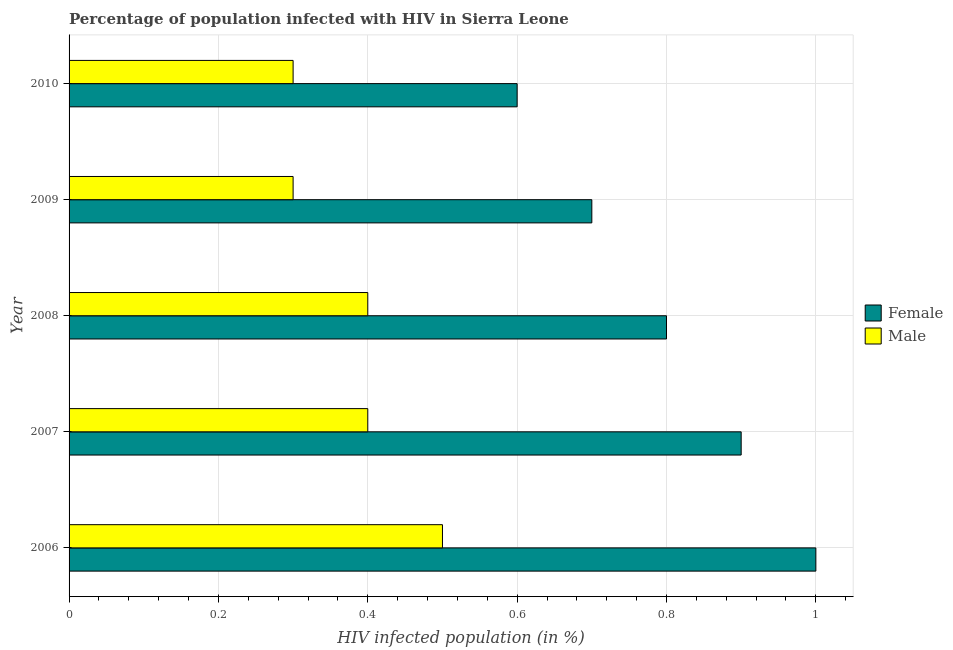How many bars are there on the 2nd tick from the top?
Offer a terse response. 2. What is the label of the 2nd group of bars from the top?
Give a very brief answer. 2009. What is the percentage of males who are infected with hiv in 2009?
Offer a very short reply. 0.3. What is the total percentage of males who are infected with hiv in the graph?
Provide a short and direct response. 1.9. What is the difference between the percentage of males who are infected with hiv in 2007 and that in 2009?
Keep it short and to the point. 0.1. What is the difference between the percentage of males who are infected with hiv in 2009 and the percentage of females who are infected with hiv in 2007?
Your answer should be very brief. -0.6. What is the average percentage of males who are infected with hiv per year?
Provide a short and direct response. 0.38. What is the ratio of the percentage of females who are infected with hiv in 2009 to that in 2010?
Offer a terse response. 1.17. Is the percentage of females who are infected with hiv in 2006 less than that in 2008?
Give a very brief answer. No. What is the difference between the highest and the lowest percentage of females who are infected with hiv?
Keep it short and to the point. 0.4. Is the sum of the percentage of males who are infected with hiv in 2007 and 2010 greater than the maximum percentage of females who are infected with hiv across all years?
Offer a very short reply. No. What does the 2nd bar from the top in 2009 represents?
Keep it short and to the point. Female. What does the 1st bar from the bottom in 2009 represents?
Provide a succinct answer. Female. How many bars are there?
Your response must be concise. 10. Are all the bars in the graph horizontal?
Your answer should be very brief. Yes. How many years are there in the graph?
Your response must be concise. 5. What is the difference between two consecutive major ticks on the X-axis?
Your answer should be very brief. 0.2. Are the values on the major ticks of X-axis written in scientific E-notation?
Offer a very short reply. No. Does the graph contain any zero values?
Offer a terse response. No. Does the graph contain grids?
Keep it short and to the point. Yes. Where does the legend appear in the graph?
Offer a terse response. Center right. What is the title of the graph?
Your answer should be compact. Percentage of population infected with HIV in Sierra Leone. What is the label or title of the X-axis?
Your answer should be very brief. HIV infected population (in %). What is the HIV infected population (in %) in Female in 2006?
Give a very brief answer. 1. What is the HIV infected population (in %) of Male in 2006?
Provide a succinct answer. 0.5. What is the HIV infected population (in %) in Female in 2007?
Your answer should be very brief. 0.9. What is the HIV infected population (in %) in Male in 2007?
Give a very brief answer. 0.4. What is the HIV infected population (in %) of Female in 2009?
Keep it short and to the point. 0.7. What is the HIV infected population (in %) of Male in 2010?
Make the answer very short. 0.3. Across all years, what is the maximum HIV infected population (in %) of Male?
Offer a terse response. 0.5. Across all years, what is the minimum HIV infected population (in %) of Female?
Offer a terse response. 0.6. Across all years, what is the minimum HIV infected population (in %) of Male?
Offer a very short reply. 0.3. What is the difference between the HIV infected population (in %) in Male in 2006 and that in 2007?
Your response must be concise. 0.1. What is the difference between the HIV infected population (in %) of Female in 2006 and that in 2008?
Make the answer very short. 0.2. What is the difference between the HIV infected population (in %) in Male in 2006 and that in 2008?
Ensure brevity in your answer.  0.1. What is the difference between the HIV infected population (in %) of Female in 2006 and that in 2010?
Give a very brief answer. 0.4. What is the difference between the HIV infected population (in %) of Male in 2007 and that in 2008?
Make the answer very short. 0. What is the difference between the HIV infected population (in %) of Male in 2007 and that in 2009?
Ensure brevity in your answer.  0.1. What is the difference between the HIV infected population (in %) of Male in 2007 and that in 2010?
Your answer should be very brief. 0.1. What is the difference between the HIV infected population (in %) in Female in 2008 and that in 2010?
Make the answer very short. 0.2. What is the difference between the HIV infected population (in %) of Male in 2008 and that in 2010?
Offer a very short reply. 0.1. What is the difference between the HIV infected population (in %) in Male in 2009 and that in 2010?
Your answer should be compact. 0. What is the difference between the HIV infected population (in %) in Female in 2006 and the HIV infected population (in %) in Male in 2008?
Your answer should be compact. 0.6. What is the difference between the HIV infected population (in %) of Female in 2006 and the HIV infected population (in %) of Male in 2009?
Make the answer very short. 0.7. What is the difference between the HIV infected population (in %) of Female in 2006 and the HIV infected population (in %) of Male in 2010?
Your answer should be very brief. 0.7. What is the difference between the HIV infected population (in %) in Female in 2007 and the HIV infected population (in %) in Male in 2008?
Offer a terse response. 0.5. What is the difference between the HIV infected population (in %) in Female in 2007 and the HIV infected population (in %) in Male in 2009?
Give a very brief answer. 0.6. What is the difference between the HIV infected population (in %) in Female in 2007 and the HIV infected population (in %) in Male in 2010?
Your answer should be very brief. 0.6. What is the difference between the HIV infected population (in %) of Female in 2008 and the HIV infected population (in %) of Male in 2010?
Make the answer very short. 0.5. What is the average HIV infected population (in %) in Male per year?
Give a very brief answer. 0.38. In the year 2006, what is the difference between the HIV infected population (in %) of Female and HIV infected population (in %) of Male?
Give a very brief answer. 0.5. In the year 2007, what is the difference between the HIV infected population (in %) of Female and HIV infected population (in %) of Male?
Give a very brief answer. 0.5. In the year 2009, what is the difference between the HIV infected population (in %) of Female and HIV infected population (in %) of Male?
Ensure brevity in your answer.  0.4. In the year 2010, what is the difference between the HIV infected population (in %) of Female and HIV infected population (in %) of Male?
Give a very brief answer. 0.3. What is the ratio of the HIV infected population (in %) of Male in 2006 to that in 2007?
Your response must be concise. 1.25. What is the ratio of the HIV infected population (in %) in Female in 2006 to that in 2008?
Provide a succinct answer. 1.25. What is the ratio of the HIV infected population (in %) in Female in 2006 to that in 2009?
Make the answer very short. 1.43. What is the ratio of the HIV infected population (in %) in Female in 2006 to that in 2010?
Give a very brief answer. 1.67. What is the ratio of the HIV infected population (in %) of Female in 2007 to that in 2008?
Offer a very short reply. 1.12. What is the ratio of the HIV infected population (in %) of Female in 2008 to that in 2009?
Make the answer very short. 1.14. What is the ratio of the HIV infected population (in %) in Male in 2008 to that in 2009?
Provide a short and direct response. 1.33. What is the ratio of the HIV infected population (in %) in Male in 2009 to that in 2010?
Your response must be concise. 1. 